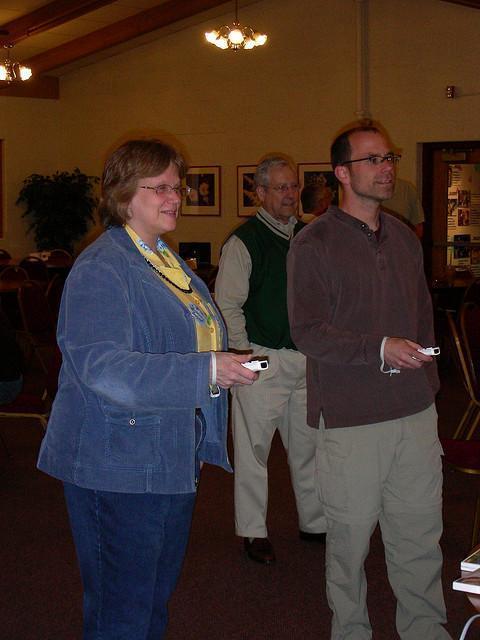How many people are playing the game?
Give a very brief answer. 2. How many people are in the image?
Give a very brief answer. 3. How many people are there?
Give a very brief answer. 3. How many giraffes are seated?
Give a very brief answer. 0. 